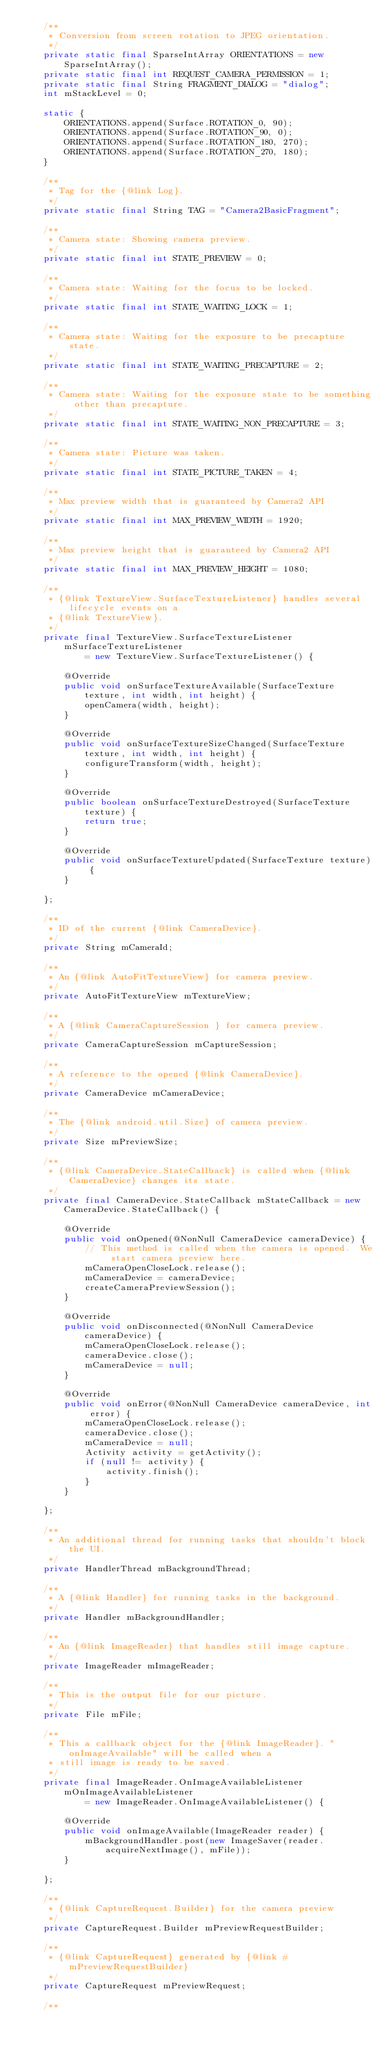Convert code to text. <code><loc_0><loc_0><loc_500><loc_500><_Java_>    /**
     * Conversion from screen rotation to JPEG orientation.
     */
    private static final SparseIntArray ORIENTATIONS = new SparseIntArray();
    private static final int REQUEST_CAMERA_PERMISSION = 1;
    private static final String FRAGMENT_DIALOG = "dialog";
    int mStackLevel = 0;

    static {
        ORIENTATIONS.append(Surface.ROTATION_0, 90);
        ORIENTATIONS.append(Surface.ROTATION_90, 0);
        ORIENTATIONS.append(Surface.ROTATION_180, 270);
        ORIENTATIONS.append(Surface.ROTATION_270, 180);
    }

    /**
     * Tag for the {@link Log}.
     */
    private static final String TAG = "Camera2BasicFragment";

    /**
     * Camera state: Showing camera preview.
     */
    private static final int STATE_PREVIEW = 0;

    /**
     * Camera state: Waiting for the focus to be locked.
     */
    private static final int STATE_WAITING_LOCK = 1;

    /**
     * Camera state: Waiting for the exposure to be precapture state.
     */
    private static final int STATE_WAITING_PRECAPTURE = 2;

    /**
     * Camera state: Waiting for the exposure state to be something other than precapture.
     */
    private static final int STATE_WAITING_NON_PRECAPTURE = 3;

    /**
     * Camera state: Picture was taken.
     */
    private static final int STATE_PICTURE_TAKEN = 4;

    /**
     * Max preview width that is guaranteed by Camera2 API
     */
    private static final int MAX_PREVIEW_WIDTH = 1920;

    /**
     * Max preview height that is guaranteed by Camera2 API
     */
    private static final int MAX_PREVIEW_HEIGHT = 1080;

    /**
     * {@link TextureView.SurfaceTextureListener} handles several lifecycle events on a
     * {@link TextureView}.
     */
    private final TextureView.SurfaceTextureListener mSurfaceTextureListener
            = new TextureView.SurfaceTextureListener() {

        @Override
        public void onSurfaceTextureAvailable(SurfaceTexture texture, int width, int height) {
            openCamera(width, height);
        }

        @Override
        public void onSurfaceTextureSizeChanged(SurfaceTexture texture, int width, int height) {
            configureTransform(width, height);
        }

        @Override
        public boolean onSurfaceTextureDestroyed(SurfaceTexture texture) {
            return true;
        }

        @Override
        public void onSurfaceTextureUpdated(SurfaceTexture texture) {
        }

    };

    /**
     * ID of the current {@link CameraDevice}.
     */
    private String mCameraId;

    /**
     * An {@link AutoFitTextureView} for camera preview.
     */
    private AutoFitTextureView mTextureView;

    /**
     * A {@link CameraCaptureSession } for camera preview.
     */
    private CameraCaptureSession mCaptureSession;

    /**
     * A reference to the opened {@link CameraDevice}.
     */
    private CameraDevice mCameraDevice;

    /**
     * The {@link android.util.Size} of camera preview.
     */
    private Size mPreviewSize;

    /**
     * {@link CameraDevice.StateCallback} is called when {@link CameraDevice} changes its state.
     */
    private final CameraDevice.StateCallback mStateCallback = new CameraDevice.StateCallback() {

        @Override
        public void onOpened(@NonNull CameraDevice cameraDevice) {
            // This method is called when the camera is opened.  We start camera preview here.
            mCameraOpenCloseLock.release();
            mCameraDevice = cameraDevice;
            createCameraPreviewSession();
        }

        @Override
        public void onDisconnected(@NonNull CameraDevice cameraDevice) {
            mCameraOpenCloseLock.release();
            cameraDevice.close();
            mCameraDevice = null;
        }

        @Override
        public void onError(@NonNull CameraDevice cameraDevice, int error) {
            mCameraOpenCloseLock.release();
            cameraDevice.close();
            mCameraDevice = null;
            Activity activity = getActivity();
            if (null != activity) {
                activity.finish();
            }
        }

    };

    /**
     * An additional thread for running tasks that shouldn't block the UI.
     */
    private HandlerThread mBackgroundThread;

    /**
     * A {@link Handler} for running tasks in the background.
     */
    private Handler mBackgroundHandler;

    /**
     * An {@link ImageReader} that handles still image capture.
     */
    private ImageReader mImageReader;

    /**
     * This is the output file for our picture.
     */
    private File mFile;

    /**
     * This a callback object for the {@link ImageReader}. "onImageAvailable" will be called when a
     * still image is ready to be saved.
     */
    private final ImageReader.OnImageAvailableListener mOnImageAvailableListener
            = new ImageReader.OnImageAvailableListener() {

        @Override
        public void onImageAvailable(ImageReader reader) {
            mBackgroundHandler.post(new ImageSaver(reader.acquireNextImage(), mFile));
        }

    };

    /**
     * {@link CaptureRequest.Builder} for the camera preview
     */
    private CaptureRequest.Builder mPreviewRequestBuilder;

    /**
     * {@link CaptureRequest} generated by {@link #mPreviewRequestBuilder}
     */
    private CaptureRequest mPreviewRequest;

    /**</code> 